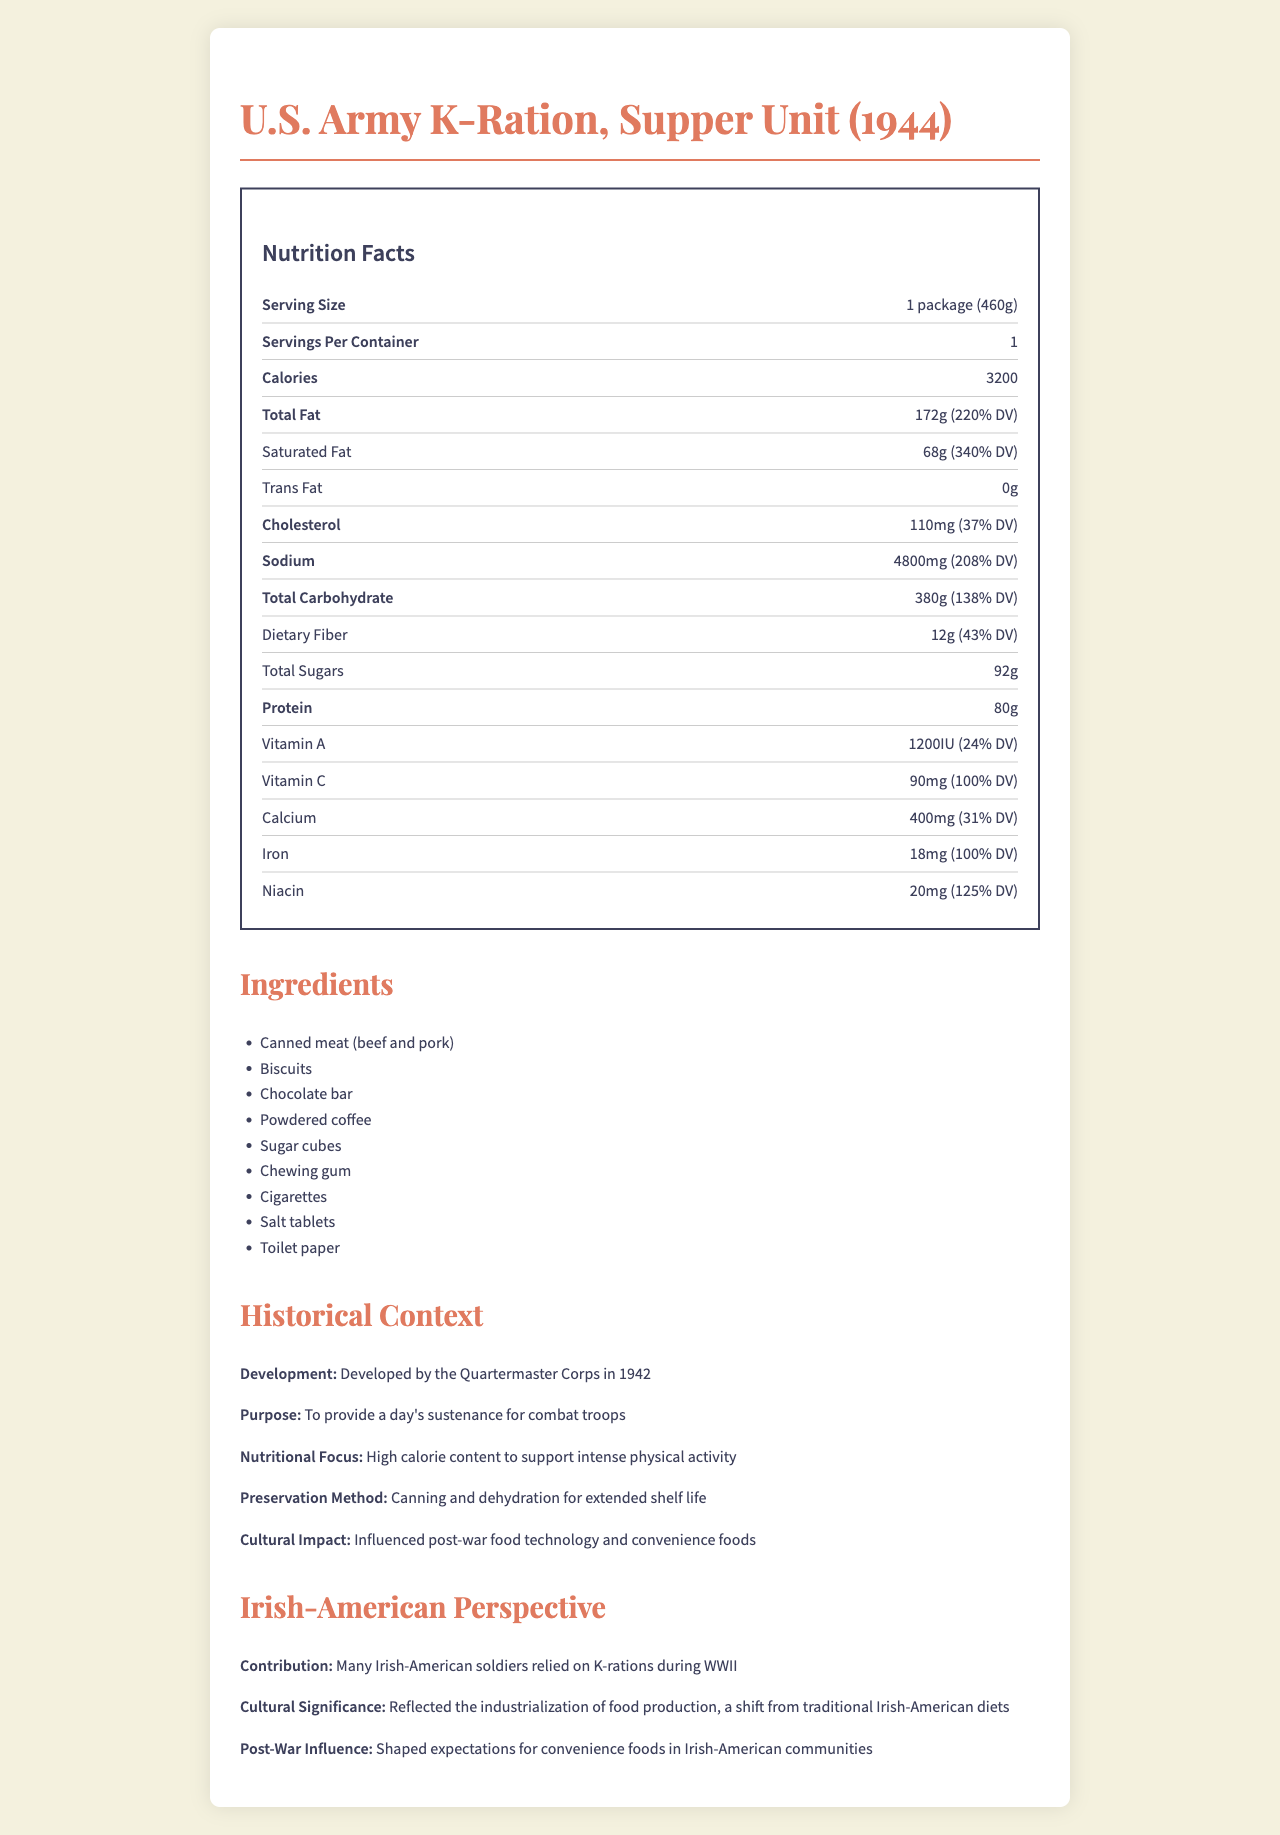what is the serving size of the K-ration? The document lists the serving size as "1 package (460g)" under the Nutrition Facts section.
Answer: 1 package (460g) what is the total calorie content of the K-ration? The document states that the K-ration has 3200 calories in the Nutrition Facts section.
Answer: 3200 calories how much saturated fat is in the K-ration? The document specifies that the K-ration contains 68g of saturated fat.
Answer: 68g what are the main ingredients in the K-ration? The Ingredients section lists these items.
Answer: Canned meat (beef and pork), Biscuits, Chocolate bar, Powdered coffee, Sugar cubes, Chewing gum, Cigarettes, Salt tablets, Toilet paper how much sodium does the K-ration contain? The document indicates that the K-ration contains 4800mg of sodium.
Answer: 4800mg what is the purpose of developing the K-ration? A. To provide high vitamin C content B. For luxury meals C. To sustain combat troops D. For weight loss The document's Historical Context section states that the purpose was "to provide a day's sustenance for combat troops."
Answer: C what is the daily value percentage of niacin in the K-ration? A. 50% B. 100% C. 125% D. 150% In the Nutrition Facts section, it is stated that niacin corresponds to 125% of the daily value.
Answer: C is the K-ration designed to have high fiber content? The document shows in the Nutrition Facts section that dietary fiber is only 12g, which is 43% of the daily value, indicating that high fiber content wasn't a primary design feature.
Answer: No does the K-ration contain trans fat? The Nutrition Facts section lists the trans fat content as 0g.
Answer: No summarize the main idea of the document. The document outlines the components of the K-ration, its nutritional content, historical background including its development by the Quartermaster Corps, and its impact on future food technology and cultural shifts in the diet of Irish-American soldiers.
Answer: The document provides detailed nutritional information about the WWII-era U.S. Army K-Ration, Supper Unit (1944), including ingredients, historical context, and its significance from an Irish-American perspective. It highlights the ration's development, purpose for combat troops, high calorie content for physical activity, preservation methods, and its cultural and post-war influence. who manufactured the K-ration? The document does not include information about the manufacturer of the K-ration.
Answer: Cannot be determined 